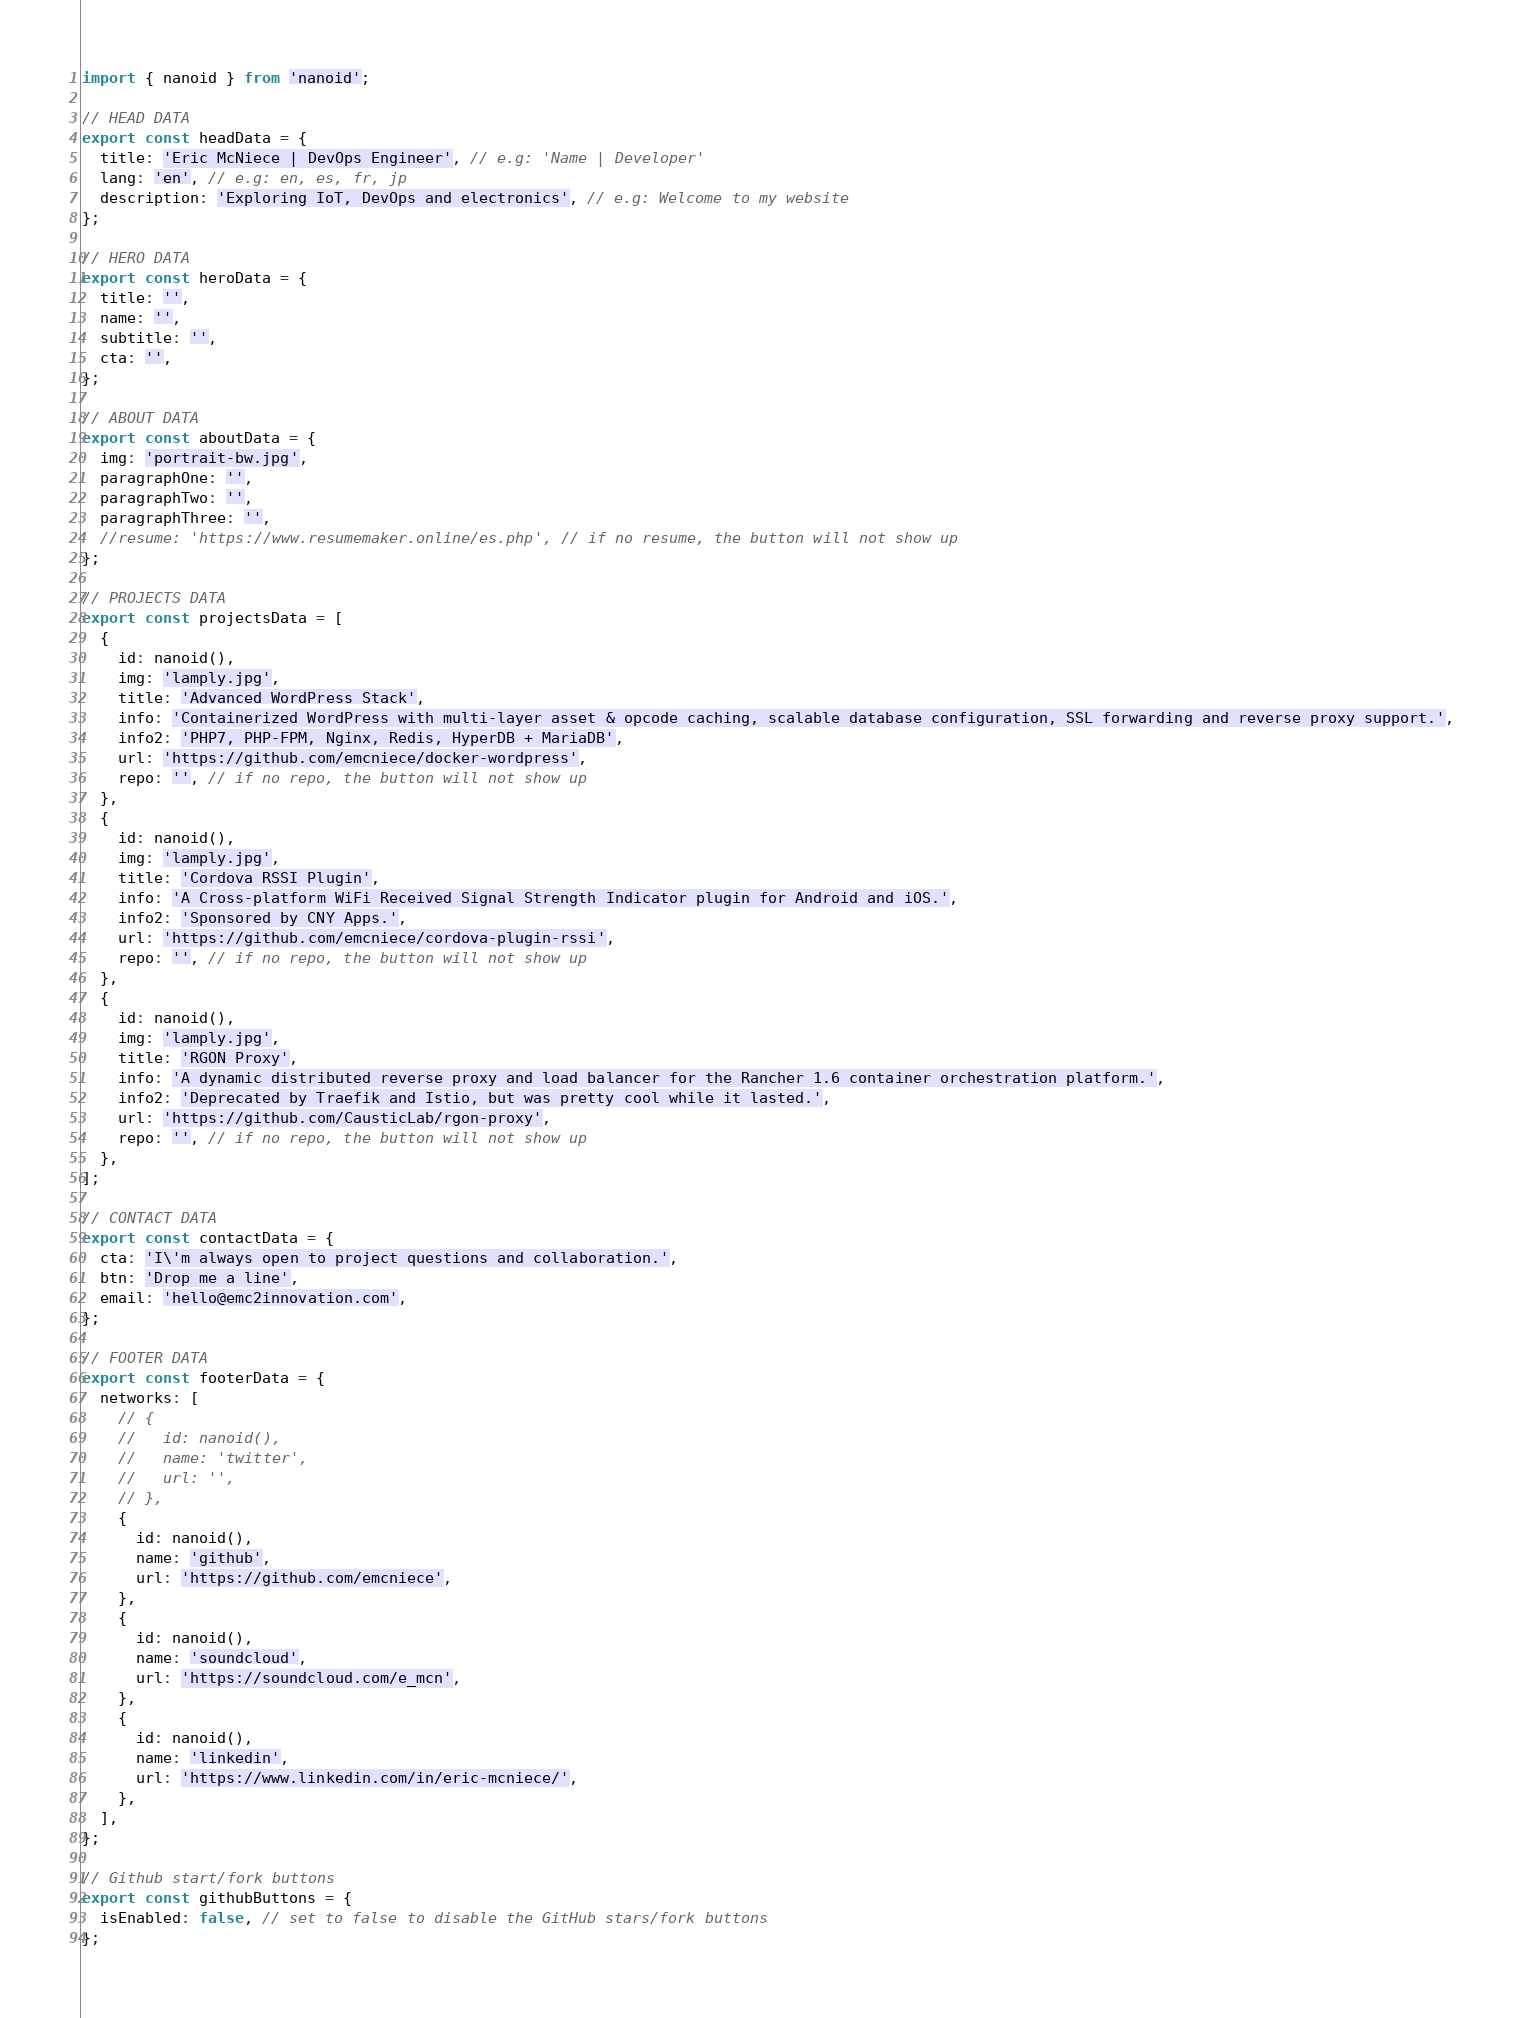Convert code to text. <code><loc_0><loc_0><loc_500><loc_500><_JavaScript_>import { nanoid } from 'nanoid';

// HEAD DATA
export const headData = {
  title: 'Eric McNiece | DevOps Engineer', // e.g: 'Name | Developer'
  lang: 'en', // e.g: en, es, fr, jp
  description: 'Exploring IoT, DevOps and electronics', // e.g: Welcome to my website
};

// HERO DATA
export const heroData = {
  title: '',
  name: '',
  subtitle: '',
  cta: '',
};

// ABOUT DATA
export const aboutData = {
  img: 'portrait-bw.jpg',
  paragraphOne: '',
  paragraphTwo: '',
  paragraphThree: '',
  //resume: 'https://www.resumemaker.online/es.php', // if no resume, the button will not show up
};

// PROJECTS DATA
export const projectsData = [
  {
    id: nanoid(),
    img: 'lamply.jpg',
    title: 'Advanced WordPress Stack',
    info: 'Containerized WordPress with multi-layer asset & opcode caching, scalable database configuration, SSL forwarding and reverse proxy support.',
    info2: 'PHP7, PHP-FPM, Nginx, Redis, HyperDB + MariaDB',
    url: 'https://github.com/emcniece/docker-wordpress',
    repo: '', // if no repo, the button will not show up
  },
  {
    id: nanoid(),
    img: 'lamply.jpg',
    title: 'Cordova RSSI Plugin',
    info: 'A Cross-platform WiFi Received Signal Strength Indicator plugin for Android and iOS.',
    info2: 'Sponsored by CNY Apps.',
    url: 'https://github.com/emcniece/cordova-plugin-rssi',
    repo: '', // if no repo, the button will not show up
  },
  {
    id: nanoid(),
    img: 'lamply.jpg',
    title: 'RGON Proxy',
    info: 'A dynamic distributed reverse proxy and load balancer for the Rancher 1.6 container orchestration platform.',
    info2: 'Deprecated by Traefik and Istio, but was pretty cool while it lasted.',
    url: 'https://github.com/CausticLab/rgon-proxy',
    repo: '', // if no repo, the button will not show up
  },
];

// CONTACT DATA
export const contactData = {
  cta: 'I\'m always open to project questions and collaboration.',
  btn: 'Drop me a line',
  email: 'hello@emc2innovation.com',
};

// FOOTER DATA
export const footerData = {
  networks: [
    // {
    //   id: nanoid(),
    //   name: 'twitter',
    //   url: '',
    // },
    {
      id: nanoid(),
      name: 'github',
      url: 'https://github.com/emcniece',
    },
    {
      id: nanoid(),
      name: 'soundcloud',
      url: 'https://soundcloud.com/e_mcn',
    },
    {
      id: nanoid(),
      name: 'linkedin',
      url: 'https://www.linkedin.com/in/eric-mcniece/',
    },
  ],
};

// Github start/fork buttons
export const githubButtons = {
  isEnabled: false, // set to false to disable the GitHub stars/fork buttons
};
</code> 